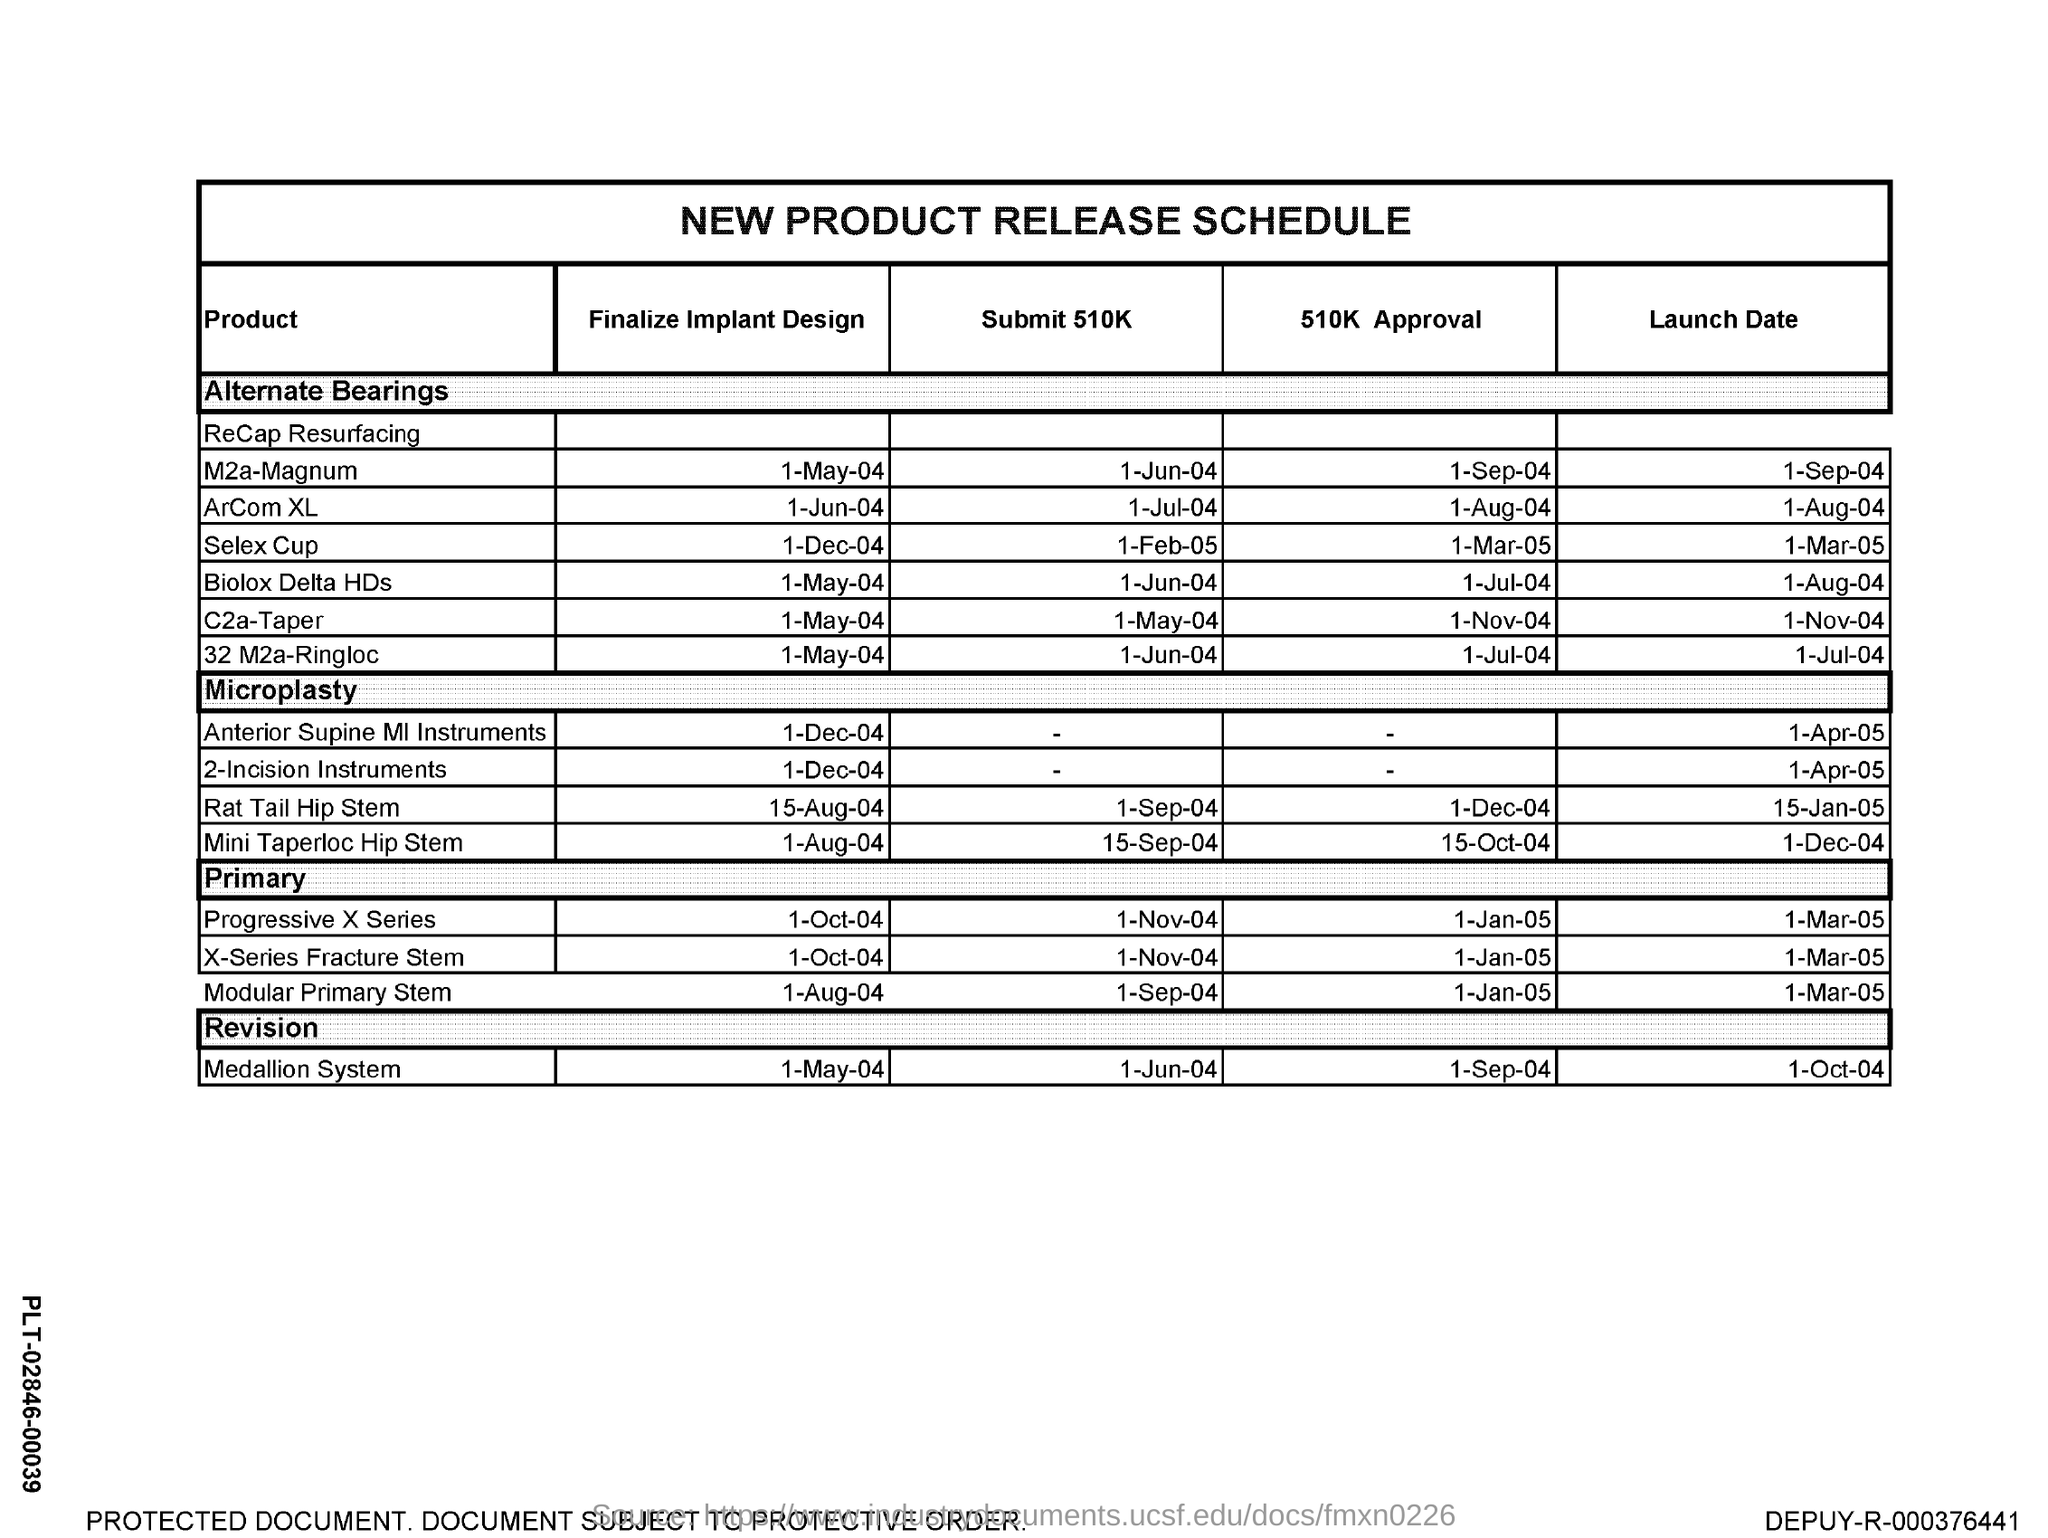What is the table about?
Ensure brevity in your answer.  NEW PRODUCT RELEASE SCHEDULE. When is the finalize Implant design of ArCom XL scheduled?
Keep it short and to the point. 1-JUN-04. When is the finalize Implant design of Selex Cup scheduled?
Your answer should be very brief. 1-DEC-04. When is the finalize Implant design of Biolox Delta HDs scheduled?
Provide a short and direct response. 1-MAY-04. When is the finalize Implant design of C2a-Taper scheduled?
Provide a short and direct response. 1-MAY-04. When is the finalize Implant design of 32 M2a-Ringloc scheduled?
Give a very brief answer. 1-MAY-04. When is the Submit 510K of ArCom XL scheduled?
Provide a short and direct response. 1-JUL-04. When is the Submit 510K of M2a-Magnum scheduled?
Offer a terse response. 1-JUN-04. When is the Submit 510K of  Selex Cup scheduled?
Keep it short and to the point. 1-FEB-05. 